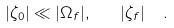Convert formula to latex. <formula><loc_0><loc_0><loc_500><loc_500>| \zeta _ { 0 } | \ll | \Omega _ { f } | , \quad | \zeta _ { f } | \ \ .</formula> 